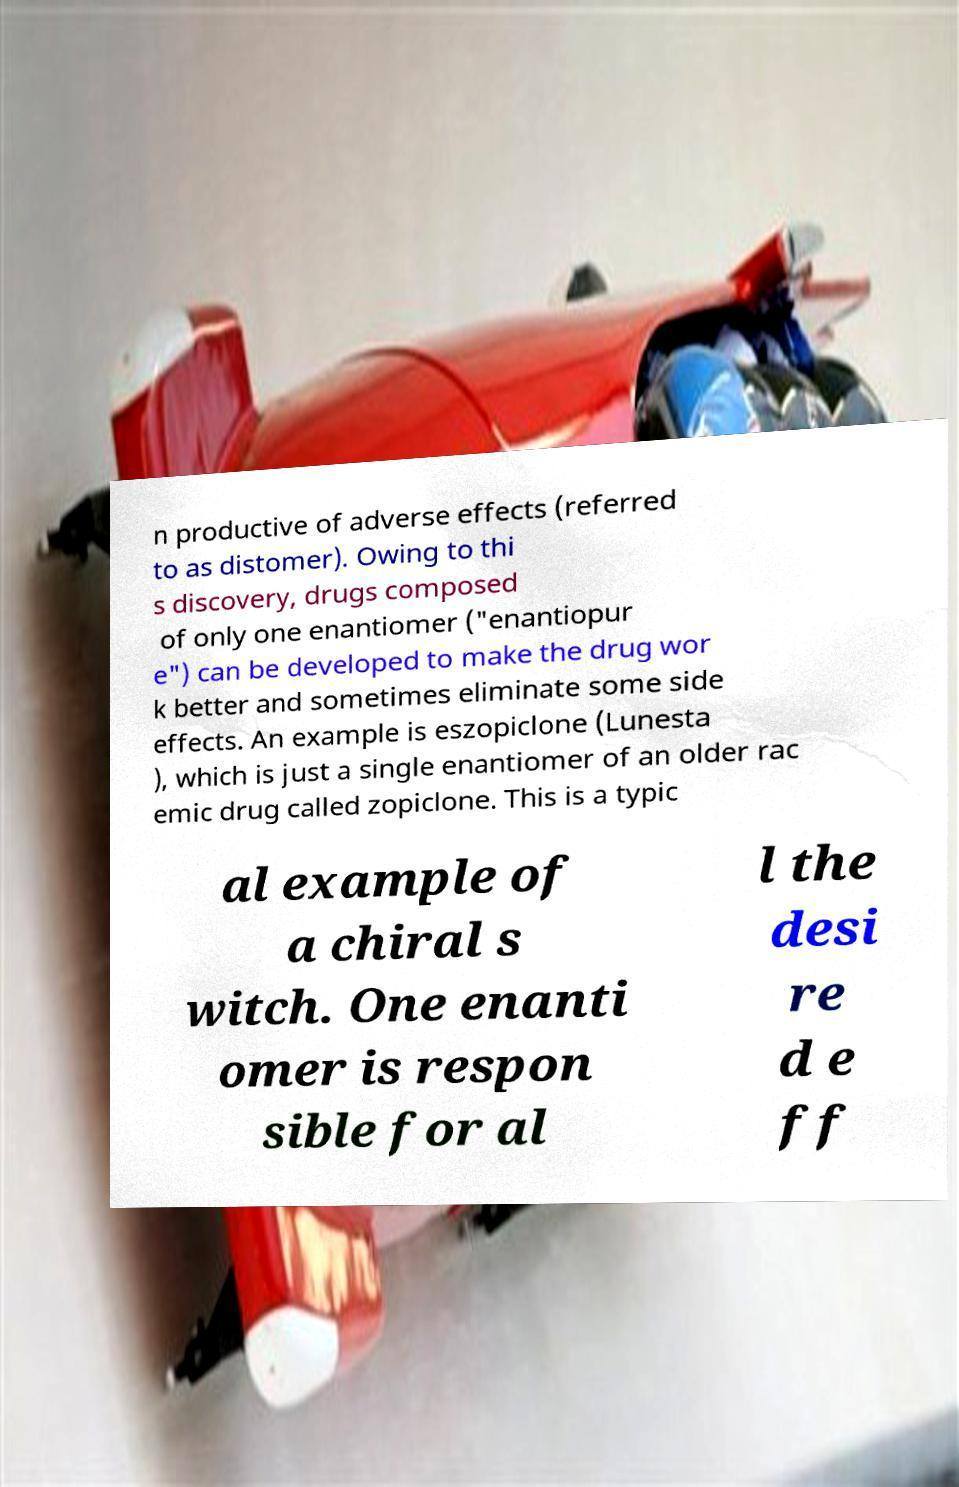There's text embedded in this image that I need extracted. Can you transcribe it verbatim? n productive of adverse effects (referred to as distomer). Owing to thi s discovery, drugs composed of only one enantiomer ("enantiopur e") can be developed to make the drug wor k better and sometimes eliminate some side effects. An example is eszopiclone (Lunesta ), which is just a single enantiomer of an older rac emic drug called zopiclone. This is a typic al example of a chiral s witch. One enanti omer is respon sible for al l the desi re d e ff 